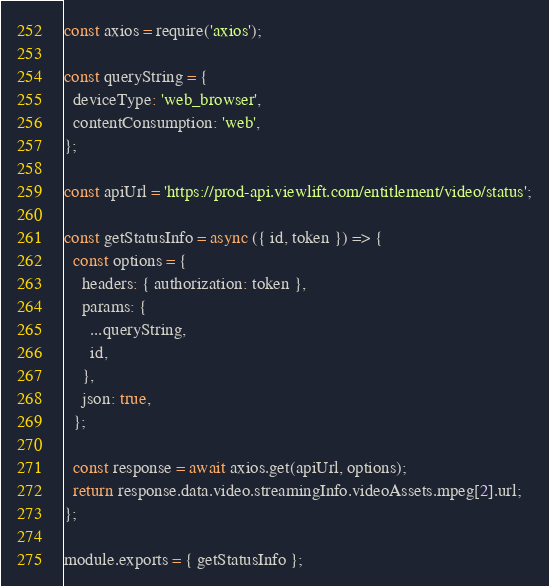Convert code to text. <code><loc_0><loc_0><loc_500><loc_500><_JavaScript_>const axios = require('axios');

const queryString = {
  deviceType: 'web_browser',
  contentConsumption: 'web',
};

const apiUrl = 'https://prod-api.viewlift.com/entitlement/video/status';

const getStatusInfo = async ({ id, token }) => {
  const options = {
    headers: { authorization: token },
    params: {
      ...queryString,
      id,
    },
    json: true,
  };

  const response = await axios.get(apiUrl, options);
  return response.data.video.streamingInfo.videoAssets.mpeg[2].url;
};

module.exports = { getStatusInfo };
</code> 